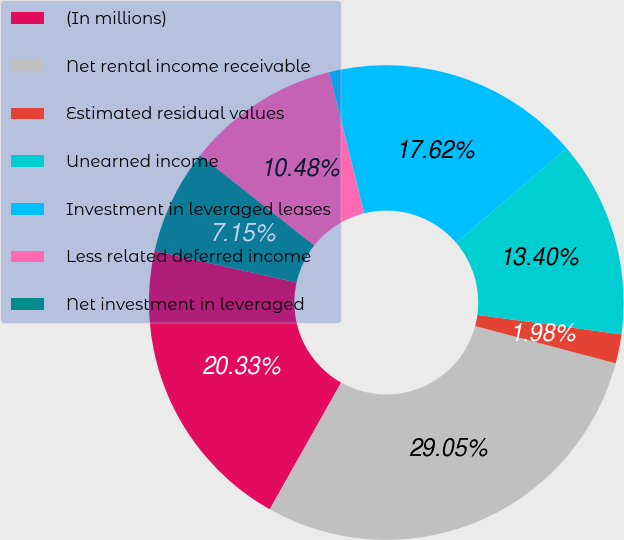Convert chart to OTSL. <chart><loc_0><loc_0><loc_500><loc_500><pie_chart><fcel>(In millions)<fcel>Net rental income receivable<fcel>Estimated residual values<fcel>Unearned income<fcel>Investment in leveraged leases<fcel>Less related deferred income<fcel>Net investment in leveraged<nl><fcel>20.33%<fcel>29.05%<fcel>1.98%<fcel>13.4%<fcel>17.62%<fcel>10.48%<fcel>7.15%<nl></chart> 